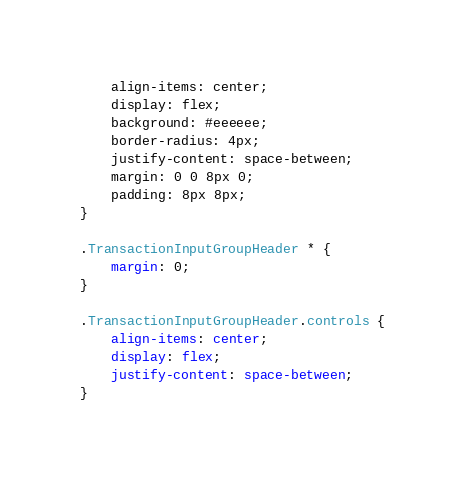Convert code to text. <code><loc_0><loc_0><loc_500><loc_500><_CSS_>    align-items: center;
    display: flex;
    background: #eeeeee;
    border-radius: 4px;
    justify-content: space-between;
    margin: 0 0 8px 0;
    padding: 8px 8px;
}

.TransactionInputGroupHeader * {
    margin: 0;
}

.TransactionInputGroupHeader.controls {
    align-items: center;
    display: flex;
    justify-content: space-between;
}</code> 